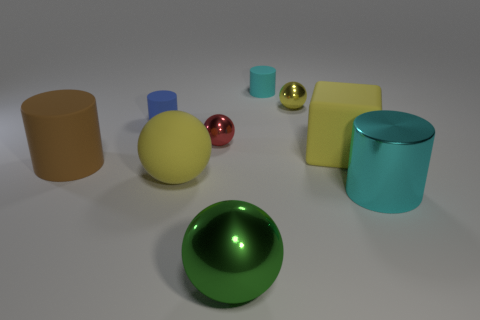Subtract all tiny blue rubber cylinders. How many cylinders are left? 3 Subtract all brown cubes. How many yellow spheres are left? 2 Subtract 4 spheres. How many spheres are left? 0 Add 1 small yellow balls. How many objects exist? 10 Subtract all brown cylinders. How many cylinders are left? 3 Subtract all blocks. How many objects are left? 8 Subtract 0 blue balls. How many objects are left? 9 Subtract all brown cylinders. Subtract all cyan blocks. How many cylinders are left? 3 Subtract all blue cylinders. Subtract all tiny metallic balls. How many objects are left? 6 Add 4 big matte balls. How many big matte balls are left? 5 